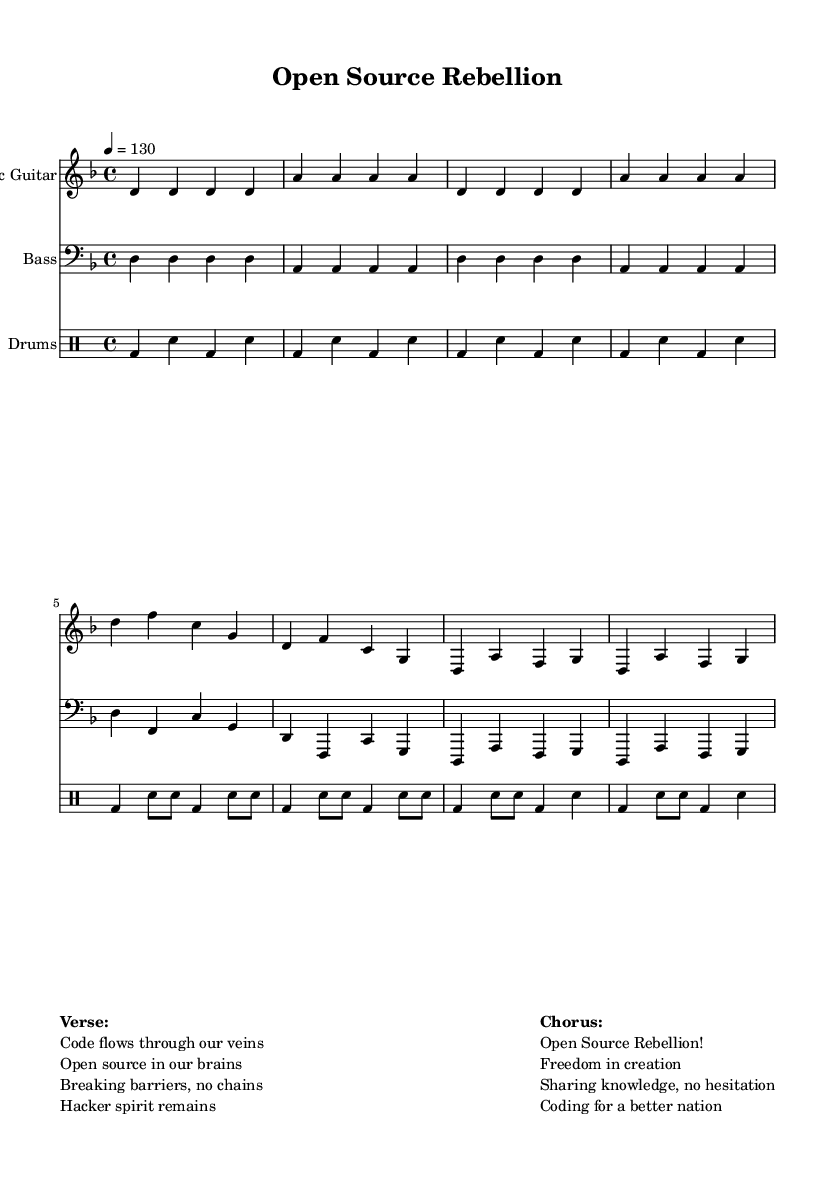What is the key signature of this music? The key signature is D minor, which contains one flat (B flat). This can typically be found at the beginning of the staff.
Answer: D minor What is the time signature of the piece? The time signature is 4/4, indicated on the staff after the key signature. This means there are four beats in a measure and a quarter note gets one beat.
Answer: 4/4 What is the tempo marking for this piece? The tempo marking is 130 beats per minute, noted in the score near the beginning. This indicates how fast the music should be played.
Answer: 130 How many measures are present in the introduction? The introduction consists of four measures, as indicated by the division of the musical phrases within the section.
Answer: 4 What instrument is used for the main melody? The main melody is played by the Electric Guitar, which is specified at the start of its staff.
Answer: Electric Guitar What is the theme of the lyrics in the chorus? The theme of the chorus revolves around the celebration of open-source collaboration and freedom in creation, as suggested by the phrases included.
Answer: Open Source Rebellion! How does the drumming pattern in the chorus compare to the verse? In the chorus, the drumming pattern maintains a similar beat but may have variations in dynamics and accents compared to the simpler rhythm prevalent in the verse. This can be analyzed by examining the notation closely for each section.
Answer: Similar but varied 